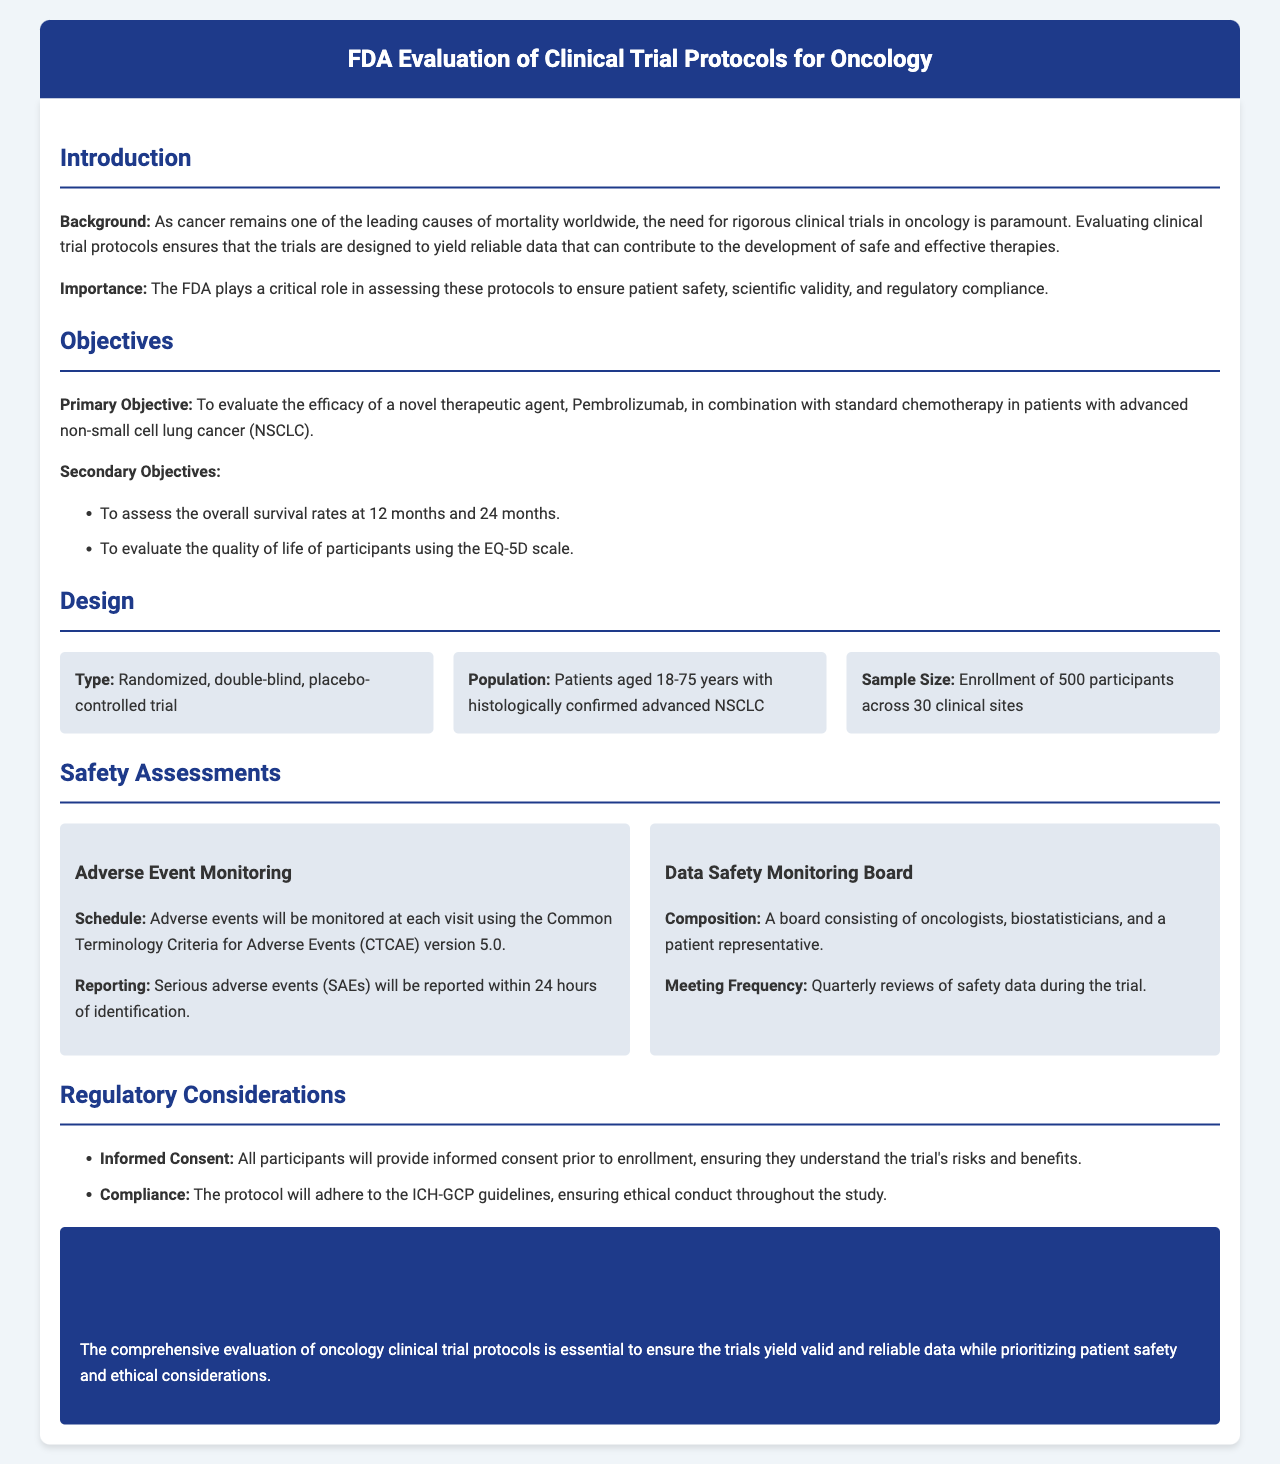What is the primary objective of the trial? The primary objective is to evaluate the efficacy of a novel therapeutic agent, Pembrolizumab, in combination with standard chemotherapy in patients with advanced non-small cell lung cancer.
Answer: Pembrolizumab How many participants will be enrolled in the study? The document states that the trial will enroll 500 participants across 30 clinical sites.
Answer: 500 participants What age range of patients is eligible for the trial? The eligible patients are aged 18-75 years with histologically confirmed advanced non-small cell lung cancer.
Answer: 18-75 years What criteria are used for adverse event monitoring? The adverse events will be monitored using the Common Terminology Criteria for Adverse Events version 5.0.
Answer: CTCAE version 5.0 How often will the Data Safety Monitoring Board meet? The Data Safety Monitoring Board meetings will occur quarterly to review safety data during the trial.
Answer: Quarterly What scale will be used to evaluate quality of life? The document mentions that the EQ-5D scale will be used to evaluate the quality of life of participants.
Answer: EQ-5D scale What is the schedule for reporting serious adverse events? Serious adverse events will be reported within 24 hours of identification.
Answer: 24 hours Which guidelines will the protocol adhere to? The protocol will adhere to the ICH-GCP guidelines, ensuring ethical conduct throughout the study.
Answer: ICH-GCP guidelines 